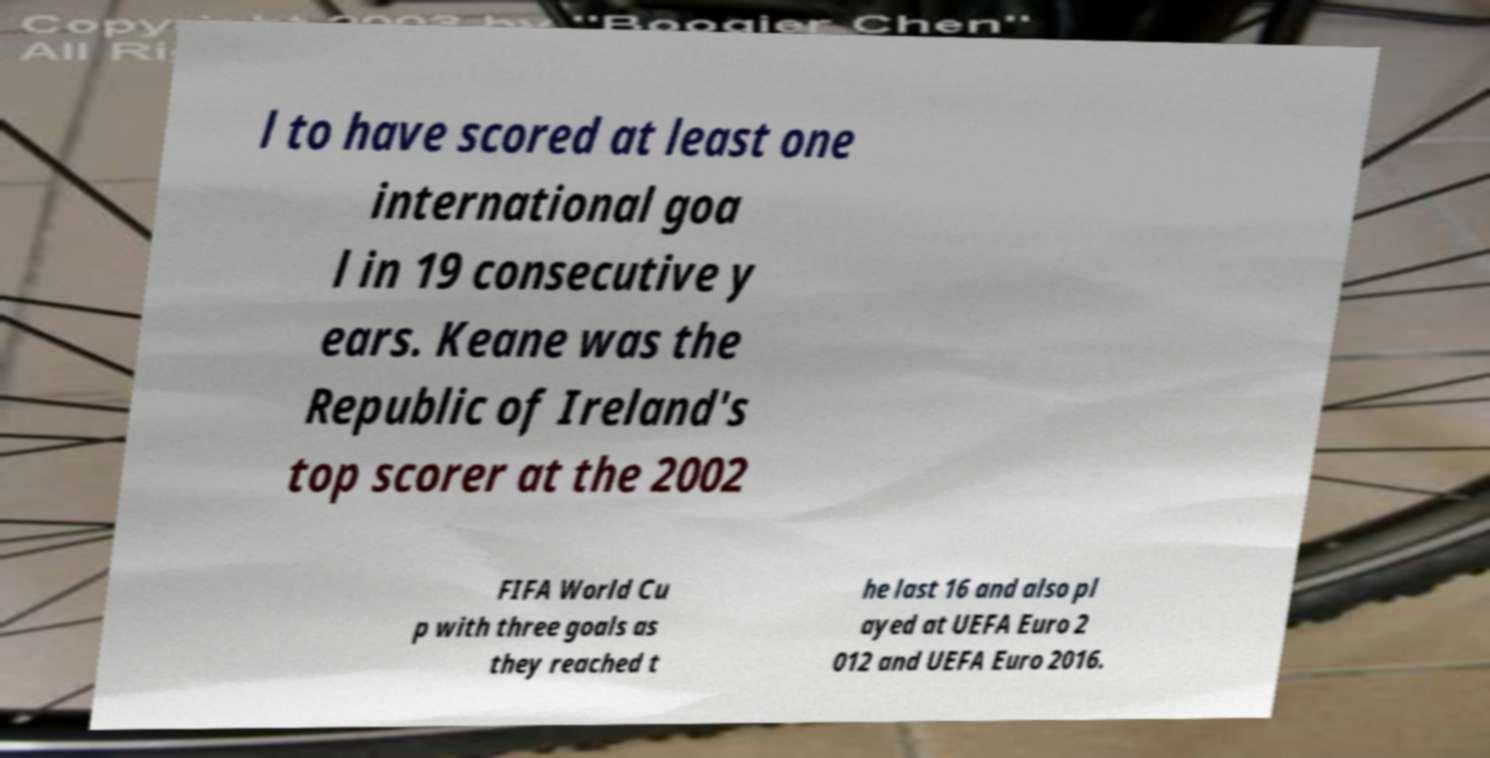For documentation purposes, I need the text within this image transcribed. Could you provide that? l to have scored at least one international goa l in 19 consecutive y ears. Keane was the Republic of Ireland's top scorer at the 2002 FIFA World Cu p with three goals as they reached t he last 16 and also pl ayed at UEFA Euro 2 012 and UEFA Euro 2016. 